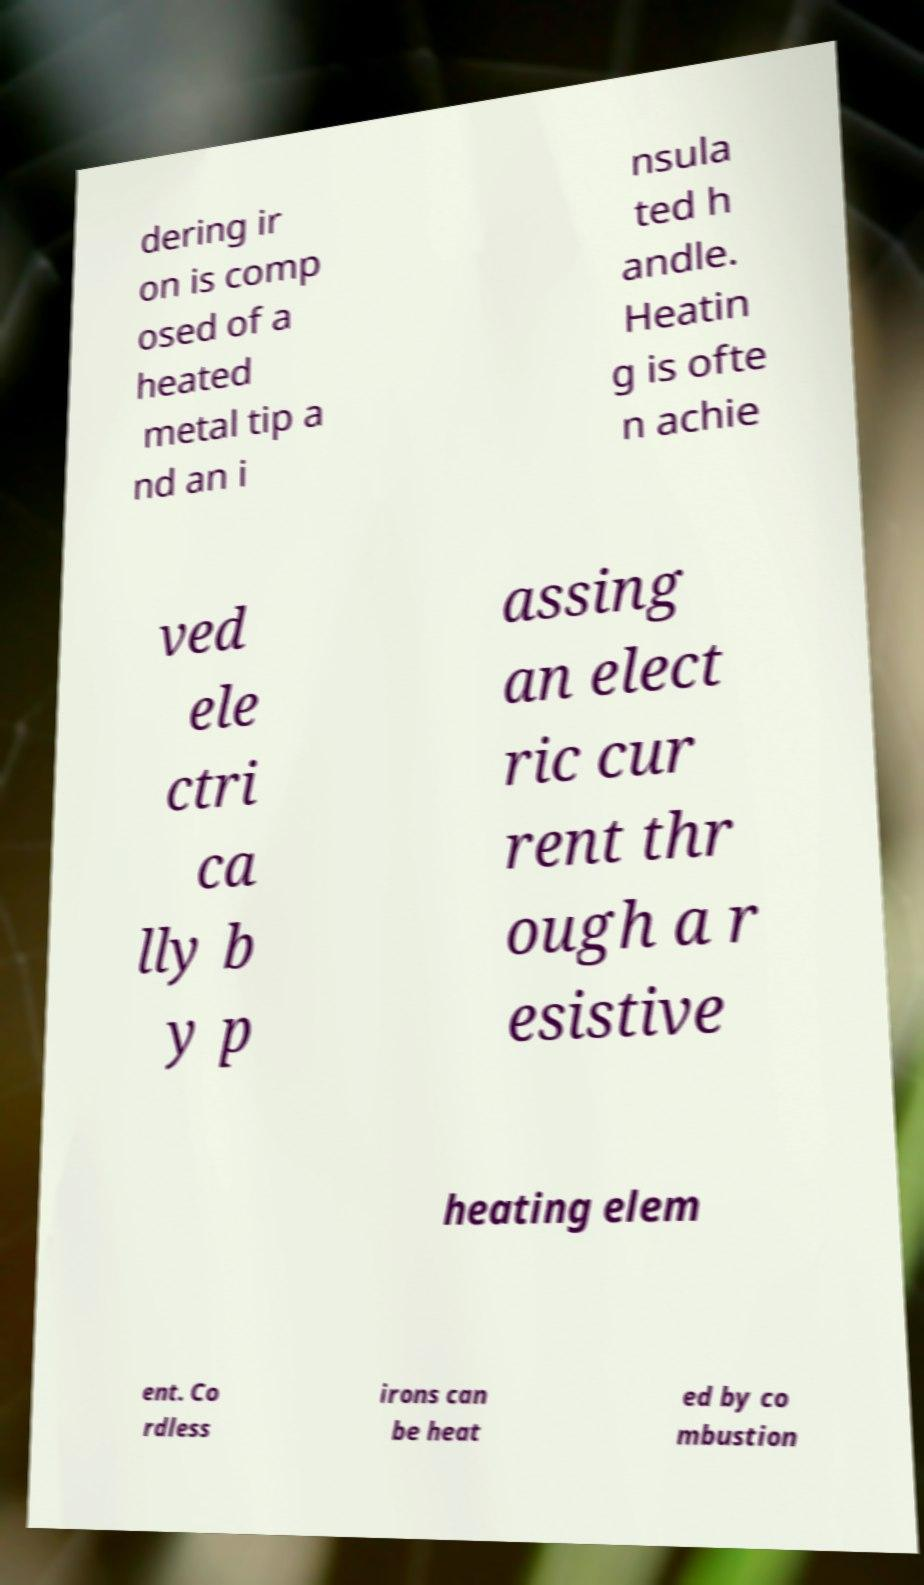Could you extract and type out the text from this image? dering ir on is comp osed of a heated metal tip a nd an i nsula ted h andle. Heatin g is ofte n achie ved ele ctri ca lly b y p assing an elect ric cur rent thr ough a r esistive heating elem ent. Co rdless irons can be heat ed by co mbustion 